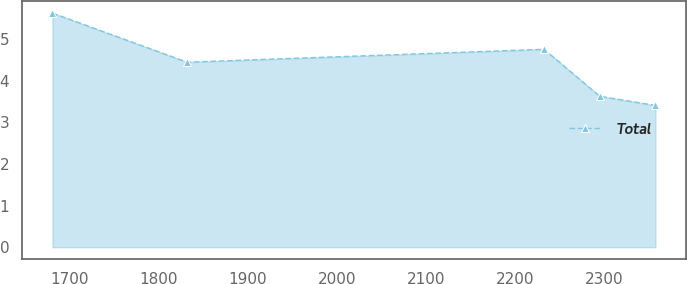Convert chart. <chart><loc_0><loc_0><loc_500><loc_500><line_chart><ecel><fcel>Total<nl><fcel>1680.71<fcel>5.63<nl><fcel>1831.97<fcel>4.45<nl><fcel>2233.06<fcel>4.76<nl><fcel>2295.59<fcel>3.63<nl><fcel>2358.12<fcel>3.41<nl></chart> 